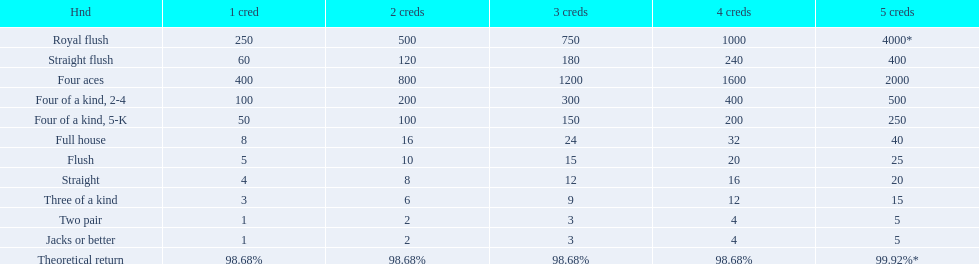What is the higher amount of points for one credit you can get from the best four of a kind 100. What type is it? Four of a kind, 2-4. 